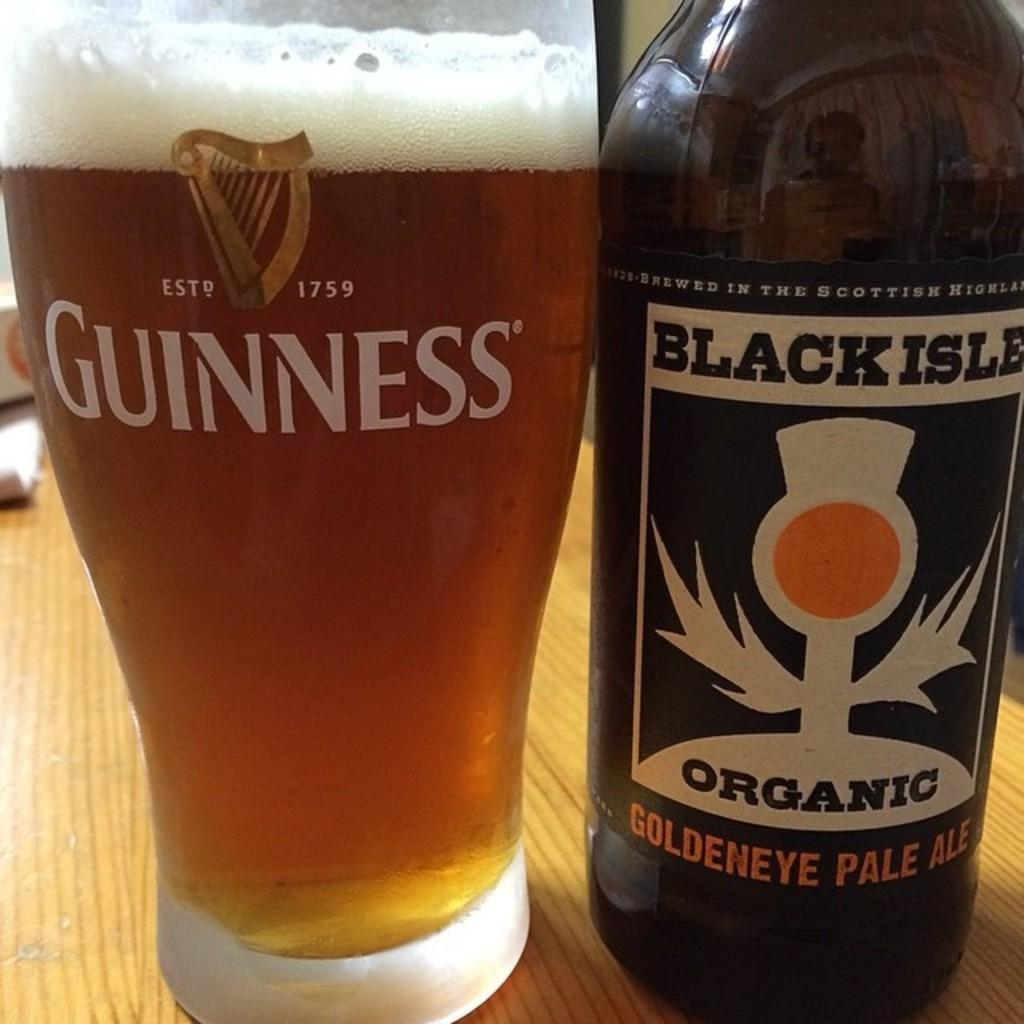<image>
Share a concise interpretation of the image provided. A full glass next to a bottle of goldeneye pale ale 